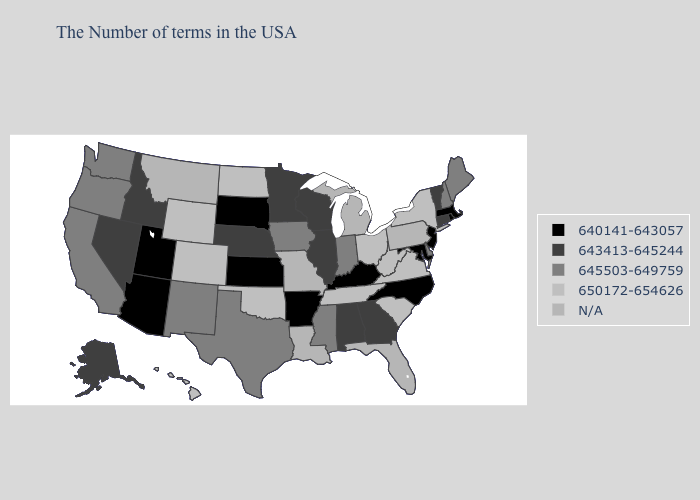What is the value of New Mexico?
Concise answer only. 645503-649759. Does West Virginia have the lowest value in the South?
Concise answer only. No. Name the states that have a value in the range 650172-654626?
Quick response, please. New York, Virginia, South Carolina, West Virginia, Ohio, Tennessee, Oklahoma, North Dakota, Wyoming, Colorado, Hawaii. Which states have the lowest value in the Northeast?
Keep it brief. Massachusetts, Rhode Island, New Jersey. Name the states that have a value in the range 650172-654626?
Give a very brief answer. New York, Virginia, South Carolina, West Virginia, Ohio, Tennessee, Oklahoma, North Dakota, Wyoming, Colorado, Hawaii. How many symbols are there in the legend?
Keep it brief. 5. What is the value of North Dakota?
Give a very brief answer. 650172-654626. Name the states that have a value in the range N/A?
Keep it brief. Pennsylvania, Florida, Michigan, Louisiana, Missouri, Montana. Among the states that border Nebraska , does Kansas have the highest value?
Give a very brief answer. No. What is the value of Hawaii?
Concise answer only. 650172-654626. Does North Dakota have the highest value in the MidWest?
Write a very short answer. Yes. 